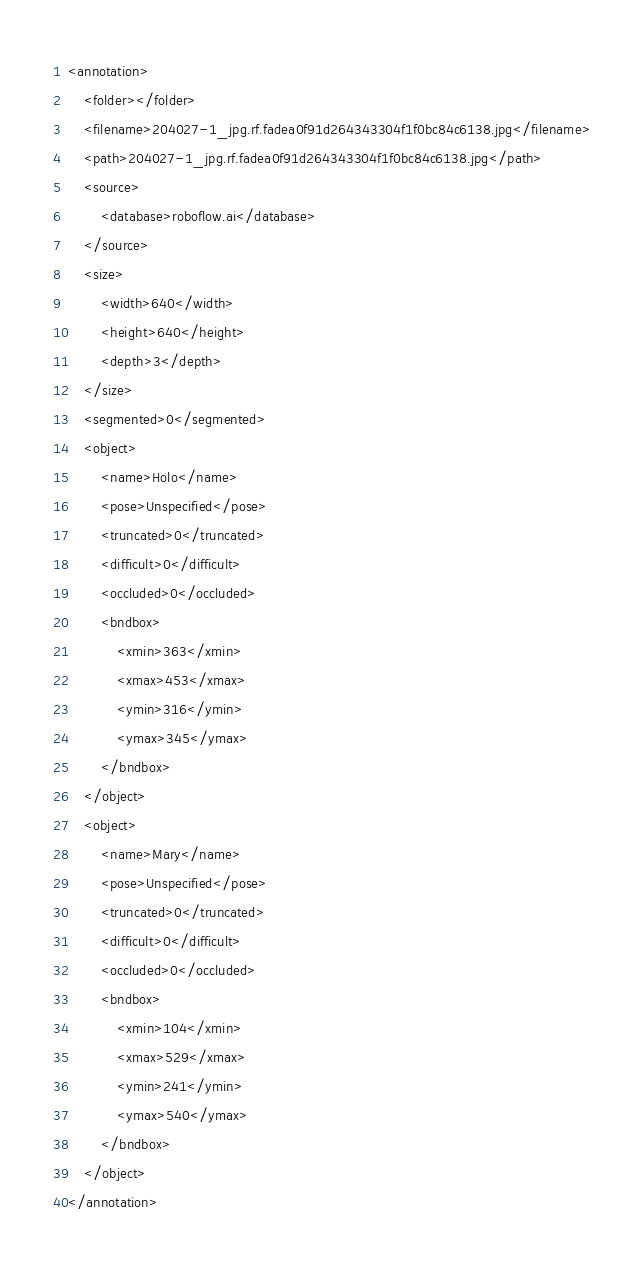<code> <loc_0><loc_0><loc_500><loc_500><_XML_><annotation>
	<folder></folder>
	<filename>204027-1_jpg.rf.fadea0f91d264343304f1f0bc84c6138.jpg</filename>
	<path>204027-1_jpg.rf.fadea0f91d264343304f1f0bc84c6138.jpg</path>
	<source>
		<database>roboflow.ai</database>
	</source>
	<size>
		<width>640</width>
		<height>640</height>
		<depth>3</depth>
	</size>
	<segmented>0</segmented>
	<object>
		<name>Holo</name>
		<pose>Unspecified</pose>
		<truncated>0</truncated>
		<difficult>0</difficult>
		<occluded>0</occluded>
		<bndbox>
			<xmin>363</xmin>
			<xmax>453</xmax>
			<ymin>316</ymin>
			<ymax>345</ymax>
		</bndbox>
	</object>
	<object>
		<name>Mary</name>
		<pose>Unspecified</pose>
		<truncated>0</truncated>
		<difficult>0</difficult>
		<occluded>0</occluded>
		<bndbox>
			<xmin>104</xmin>
			<xmax>529</xmax>
			<ymin>241</ymin>
			<ymax>540</ymax>
		</bndbox>
	</object>
</annotation>
</code> 